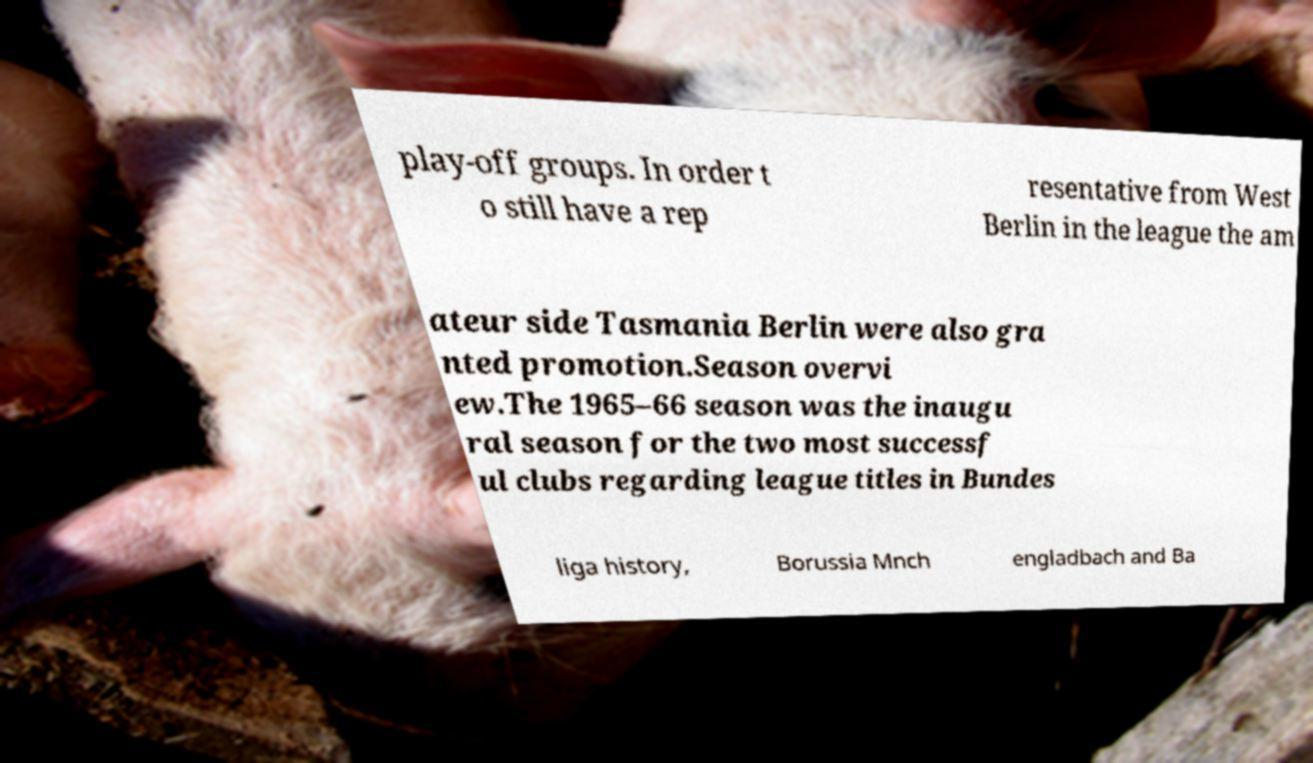What messages or text are displayed in this image? I need them in a readable, typed format. play-off groups. In order t o still have a rep resentative from West Berlin in the league the am ateur side Tasmania Berlin were also gra nted promotion.Season overvi ew.The 1965–66 season was the inaugu ral season for the two most successf ul clubs regarding league titles in Bundes liga history, Borussia Mnch engladbach and Ba 